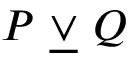Convert formula to latex. <formula><loc_0><loc_0><loc_500><loc_500>P \ { \underline { \lor } } \ Q</formula> 